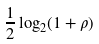<formula> <loc_0><loc_0><loc_500><loc_500>\frac { 1 } { 2 } \log _ { 2 } ( 1 + \rho )</formula> 